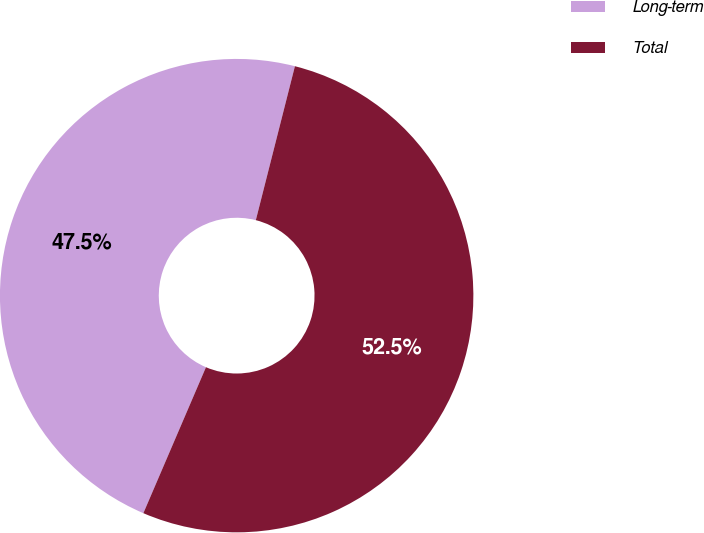<chart> <loc_0><loc_0><loc_500><loc_500><pie_chart><fcel>Long-term<fcel>Total<nl><fcel>47.51%<fcel>52.49%<nl></chart> 